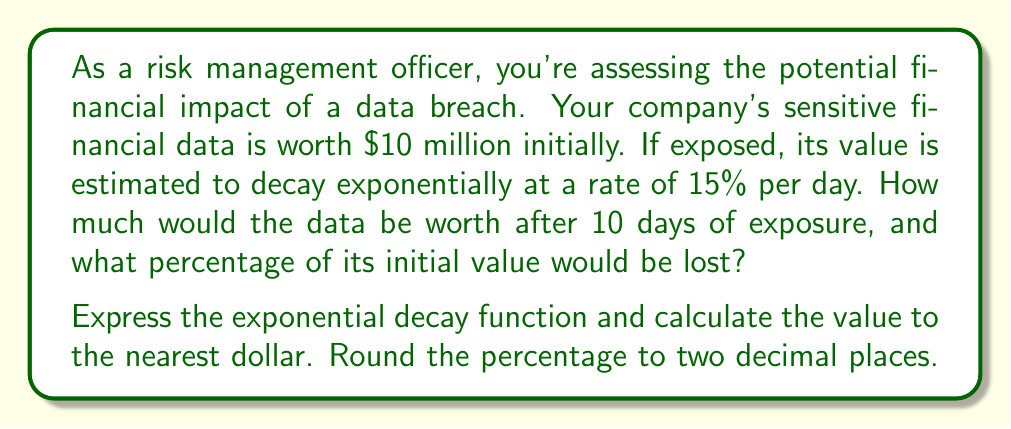Help me with this question. Let's approach this step-by-step:

1) The general form of an exponential decay function is:

   $$A(t) = A_0 \cdot e^{-rt}$$

   Where:
   $A(t)$ is the amount at time $t$
   $A_0$ is the initial amount
   $r$ is the decay rate
   $t$ is the time

2) In this case:
   $A_0 = \$10,000,000$
   $r = 0.15$ (15% expressed as a decimal)
   $t = 10$ days

3) Plugging these values into the equation:

   $$A(10) = 10,000,000 \cdot e^{-0.15 \cdot 10}$$

4) Simplify:
   $$A(10) = 10,000,000 \cdot e^{-1.5}$$

5) Calculate (using a calculator):
   $$A(10) = 10,000,000 \cdot 0.22313016...$$
   $$A(10) = 2,231,301.60...$$

6) Rounding to the nearest dollar:
   $$A(10) = \$2,231,302$$

7) To calculate the percentage lost:
   
   Percentage lost = $\frac{\text{Initial Value} - \text{Final Value}}{\text{Initial Value}} \times 100\%$

   $$\frac{10,000,000 - 2,231,302}{10,000,000} \times 100\% = 77.6870\%$$

8) Rounding to two decimal places:
   Percentage lost = 77.69%
Answer: After 10 days, the data would be worth $2,231,302. The percentage of its initial value lost would be 77.69%. 